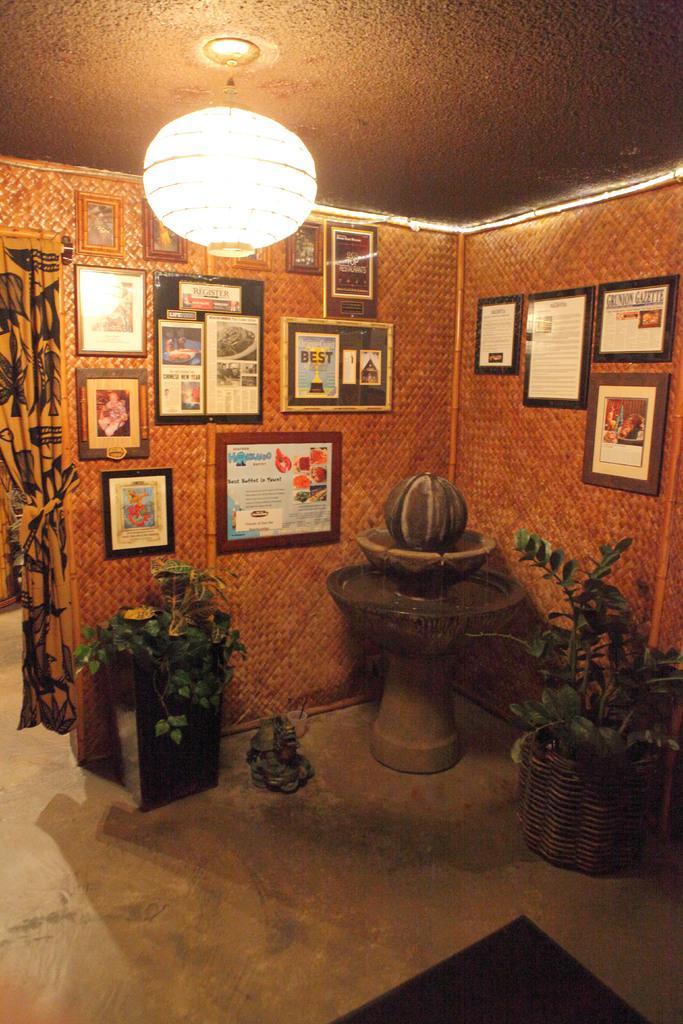Can you describe this image briefly? Here we can see house plants on the floor,frames on the wall,curtain,light hanging to the roof top,mat and an other object on the floor. 